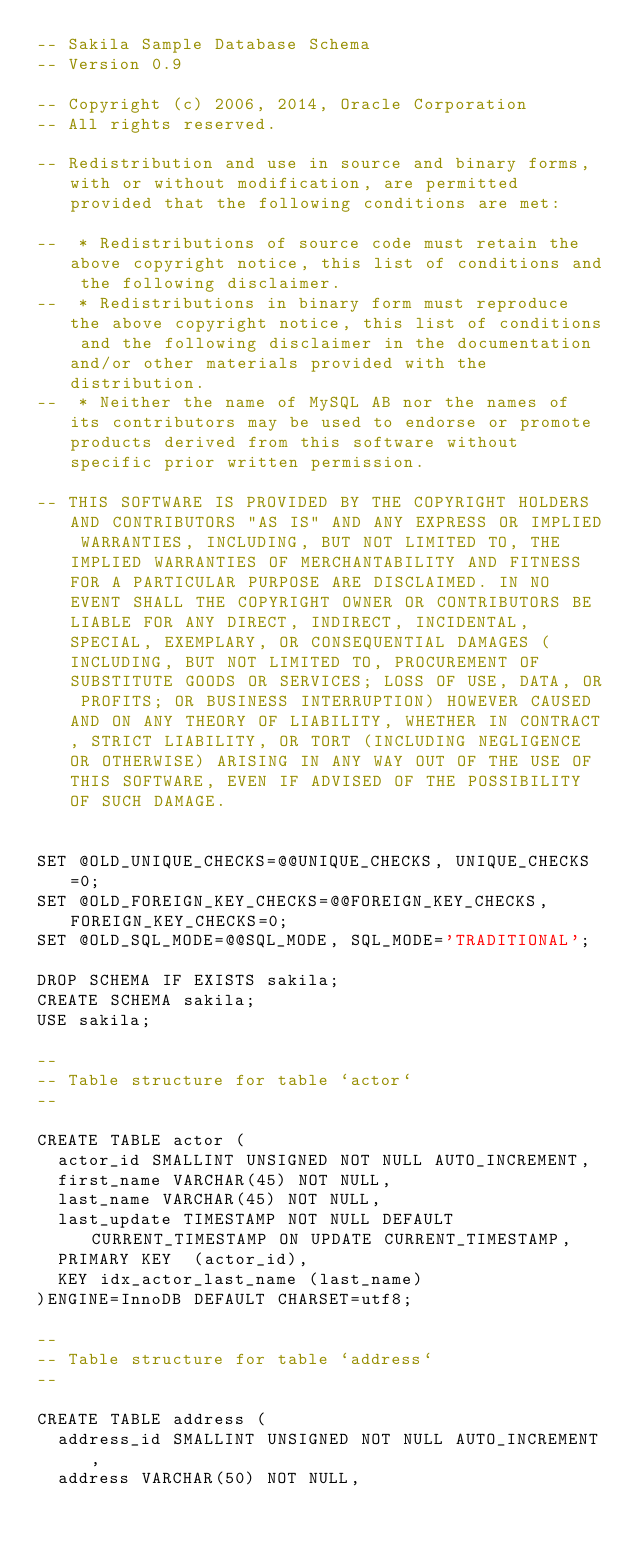<code> <loc_0><loc_0><loc_500><loc_500><_SQL_>-- Sakila Sample Database Schema
-- Version 0.9

-- Copyright (c) 2006, 2014, Oracle Corporation
-- All rights reserved.

-- Redistribution and use in source and binary forms, with or without modification, are permitted provided that the following conditions are met:

--  * Redistributions of source code must retain the above copyright notice, this list of conditions and the following disclaimer.
--  * Redistributions in binary form must reproduce the above copyright notice, this list of conditions and the following disclaimer in the documentation and/or other materials provided with the distribution.
--  * Neither the name of MySQL AB nor the names of its contributors may be used to endorse or promote products derived from this software without specific prior written permission.

-- THIS SOFTWARE IS PROVIDED BY THE COPYRIGHT HOLDERS AND CONTRIBUTORS "AS IS" AND ANY EXPRESS OR IMPLIED WARRANTIES, INCLUDING, BUT NOT LIMITED TO, THE IMPLIED WARRANTIES OF MERCHANTABILITY AND FITNESS FOR A PARTICULAR PURPOSE ARE DISCLAIMED. IN NO EVENT SHALL THE COPYRIGHT OWNER OR CONTRIBUTORS BE LIABLE FOR ANY DIRECT, INDIRECT, INCIDENTAL, SPECIAL, EXEMPLARY, OR CONSEQUENTIAL DAMAGES (INCLUDING, BUT NOT LIMITED TO, PROCUREMENT OF SUBSTITUTE GOODS OR SERVICES; LOSS OF USE, DATA, OR PROFITS; OR BUSINESS INTERRUPTION) HOWEVER CAUSED AND ON ANY THEORY OF LIABILITY, WHETHER IN CONTRACT, STRICT LIABILITY, OR TORT (INCLUDING NEGLIGENCE OR OTHERWISE) ARISING IN ANY WAY OUT OF THE USE OF THIS SOFTWARE, EVEN IF ADVISED OF THE POSSIBILITY OF SUCH DAMAGE.


SET @OLD_UNIQUE_CHECKS=@@UNIQUE_CHECKS, UNIQUE_CHECKS=0;
SET @OLD_FOREIGN_KEY_CHECKS=@@FOREIGN_KEY_CHECKS, FOREIGN_KEY_CHECKS=0;
SET @OLD_SQL_MODE=@@SQL_MODE, SQL_MODE='TRADITIONAL';

DROP SCHEMA IF EXISTS sakila;
CREATE SCHEMA sakila;
USE sakila;

--
-- Table structure for table `actor`
--

CREATE TABLE actor (
  actor_id SMALLINT UNSIGNED NOT NULL AUTO_INCREMENT,
  first_name VARCHAR(45) NOT NULL,
  last_name VARCHAR(45) NOT NULL,
  last_update TIMESTAMP NOT NULL DEFAULT CURRENT_TIMESTAMP ON UPDATE CURRENT_TIMESTAMP,
  PRIMARY KEY  (actor_id),
  KEY idx_actor_last_name (last_name)
)ENGINE=InnoDB DEFAULT CHARSET=utf8;

--
-- Table structure for table `address`
--

CREATE TABLE address (
  address_id SMALLINT UNSIGNED NOT NULL AUTO_INCREMENT,
  address VARCHAR(50) NOT NULL,</code> 